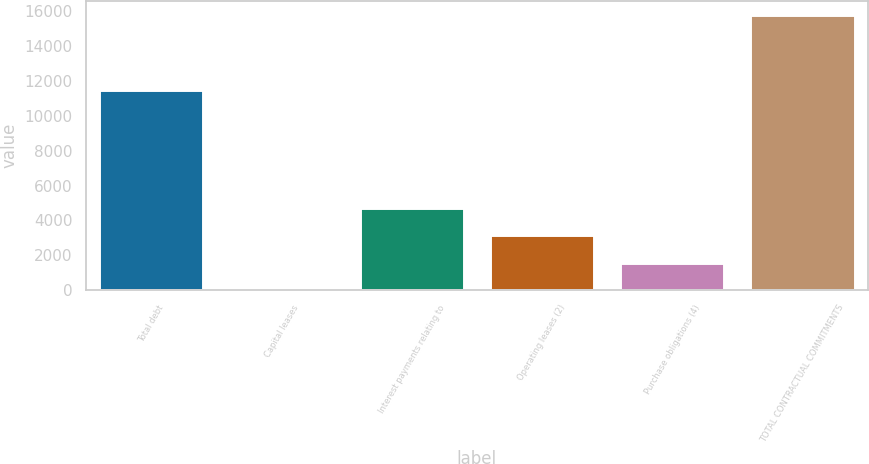<chart> <loc_0><loc_0><loc_500><loc_500><bar_chart><fcel>Total debt<fcel>Capital leases<fcel>Interest payments relating to<fcel>Operating leases (2)<fcel>Purchase obligations (4)<fcel>TOTAL CONTRACTUAL COMMITMENTS<nl><fcel>11459<fcel>3<fcel>4735.8<fcel>3158.2<fcel>1580.6<fcel>15779<nl></chart> 